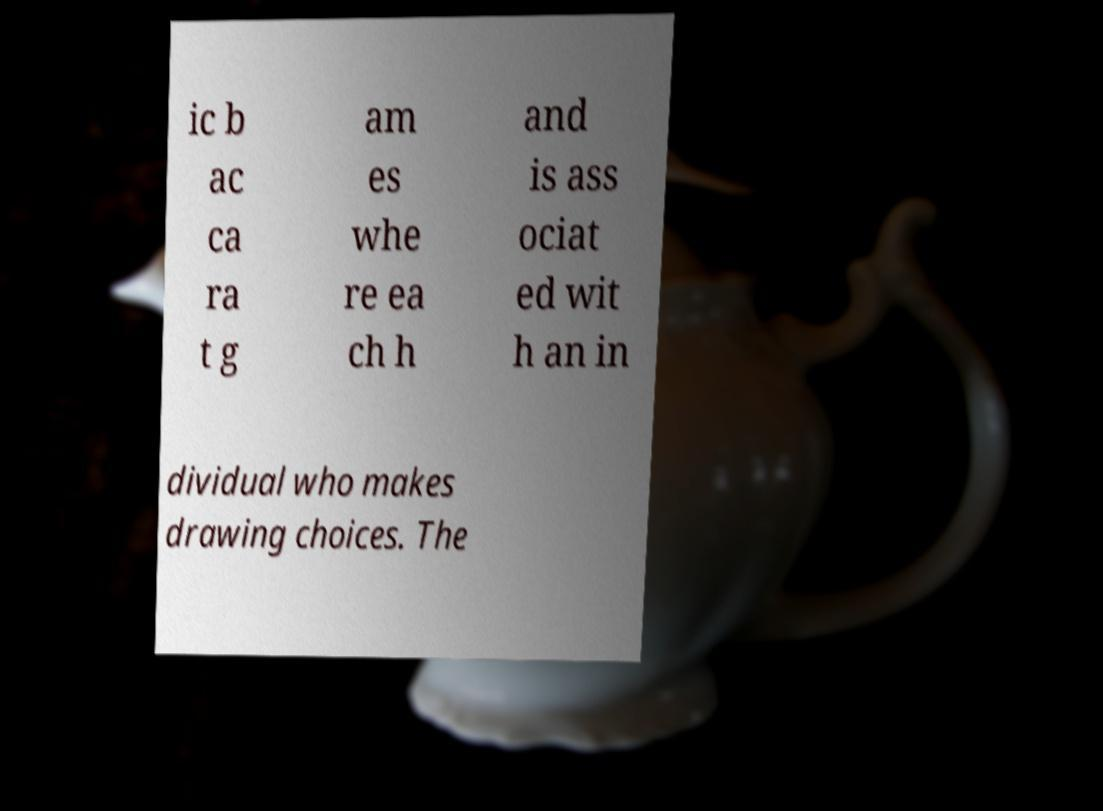Can you read and provide the text displayed in the image?This photo seems to have some interesting text. Can you extract and type it out for me? ic b ac ca ra t g am es whe re ea ch h and is ass ociat ed wit h an in dividual who makes drawing choices. The 